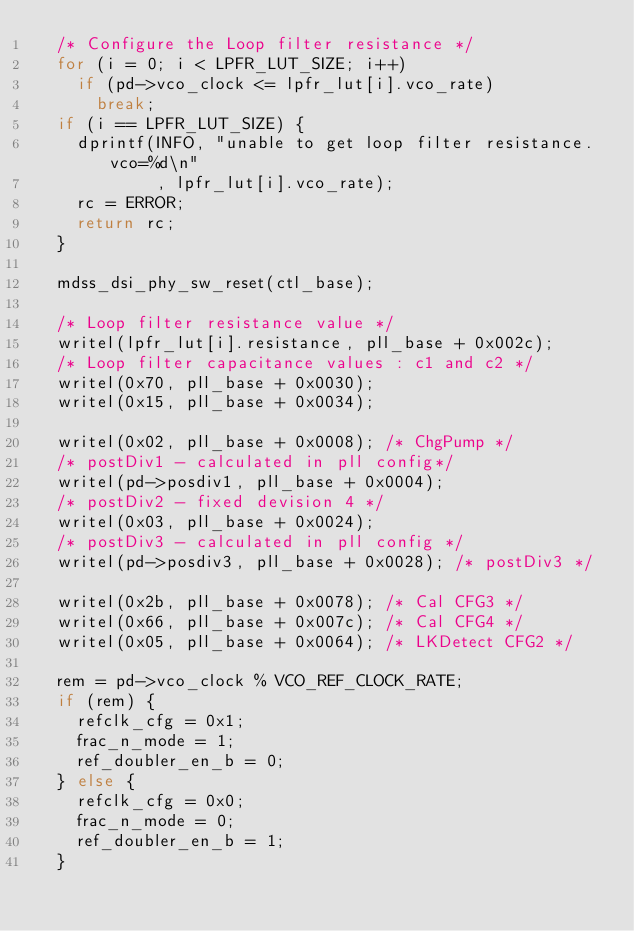Convert code to text. <code><loc_0><loc_0><loc_500><loc_500><_C_>	/* Configure the Loop filter resistance */
	for (i = 0; i < LPFR_LUT_SIZE; i++)
		if (pd->vco_clock <= lpfr_lut[i].vco_rate)
			break;
	if (i == LPFR_LUT_SIZE) {
		dprintf(INFO, "unable to get loop filter resistance. vco=%d\n"
						, lpfr_lut[i].vco_rate);
		rc = ERROR;
		return rc;
	}

	mdss_dsi_phy_sw_reset(ctl_base);

	/* Loop filter resistance value */
	writel(lpfr_lut[i].resistance, pll_base + 0x002c);
	/* Loop filter capacitance values : c1 and c2 */
	writel(0x70, pll_base + 0x0030);
	writel(0x15, pll_base + 0x0034);

	writel(0x02, pll_base + 0x0008); /* ChgPump */
	/* postDiv1 - calculated in pll config*/
	writel(pd->posdiv1, pll_base + 0x0004);
	/* postDiv2 - fixed devision 4 */
	writel(0x03, pll_base + 0x0024);
	/* postDiv3 - calculated in pll config */
	writel(pd->posdiv3, pll_base + 0x0028); /* postDiv3 */

	writel(0x2b, pll_base + 0x0078); /* Cal CFG3 */
	writel(0x66, pll_base + 0x007c); /* Cal CFG4 */
	writel(0x05, pll_base + 0x0064); /* LKDetect CFG2 */

	rem = pd->vco_clock % VCO_REF_CLOCK_RATE;
	if (rem) {
		refclk_cfg = 0x1;
		frac_n_mode = 1;
		ref_doubler_en_b = 0;
	} else {
		refclk_cfg = 0x0;
		frac_n_mode = 0;
		ref_doubler_en_b = 1;
	}
</code> 